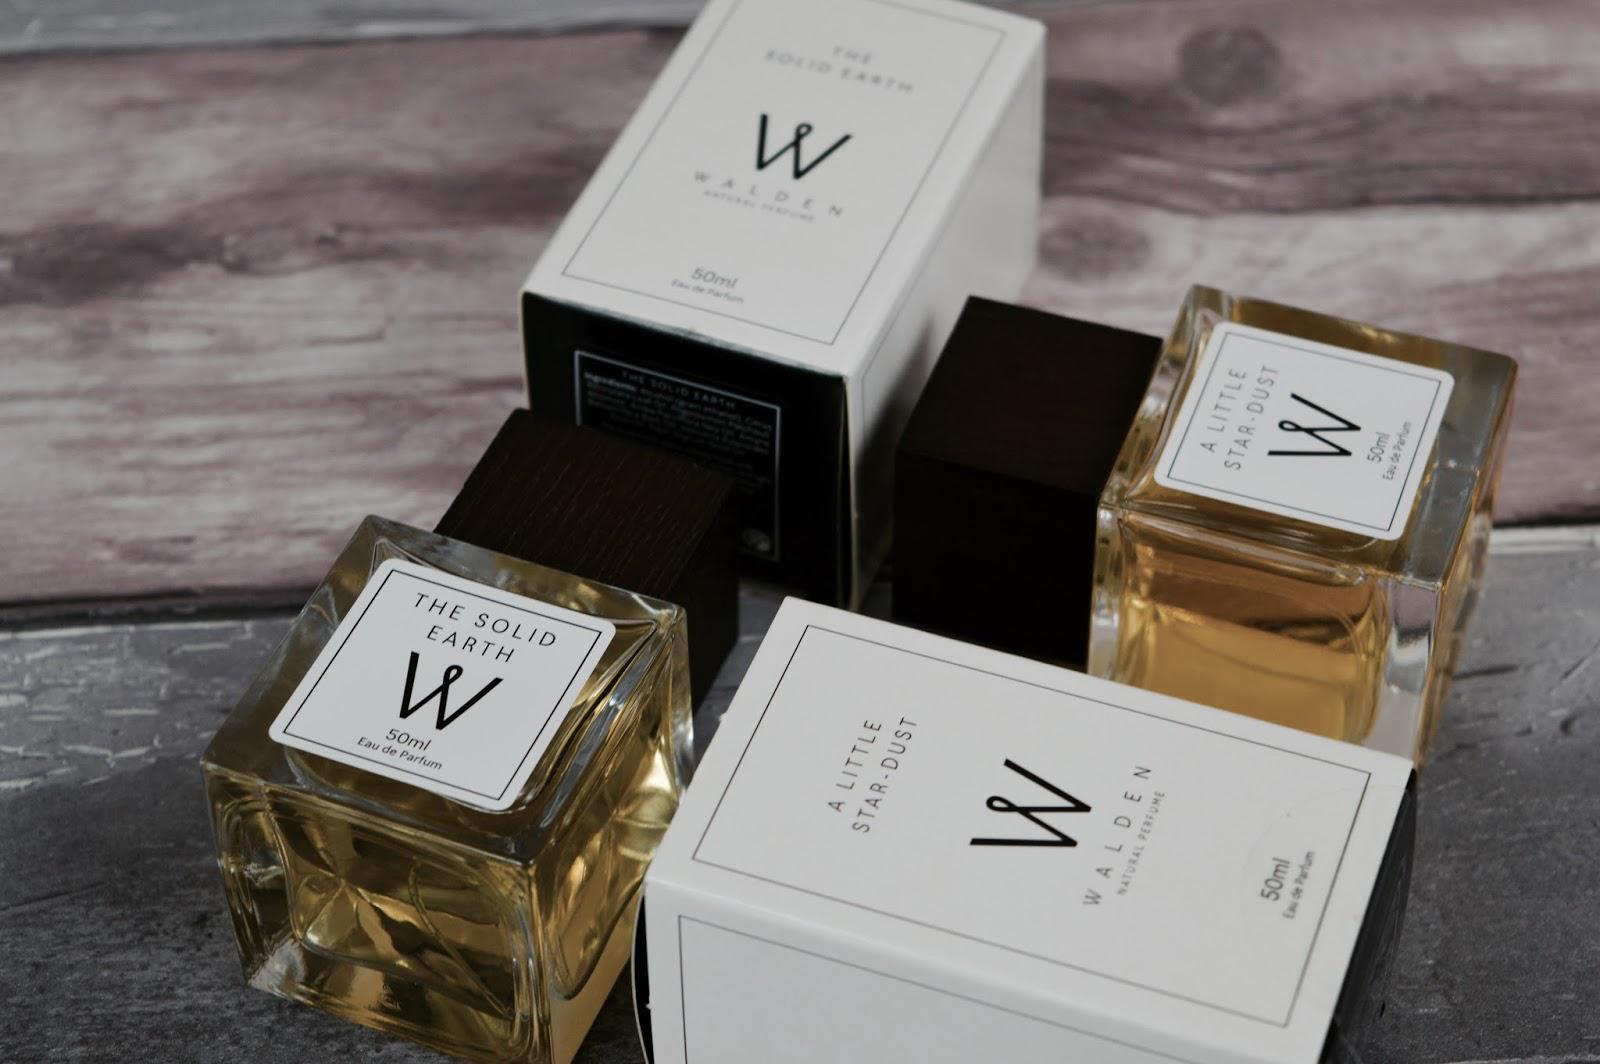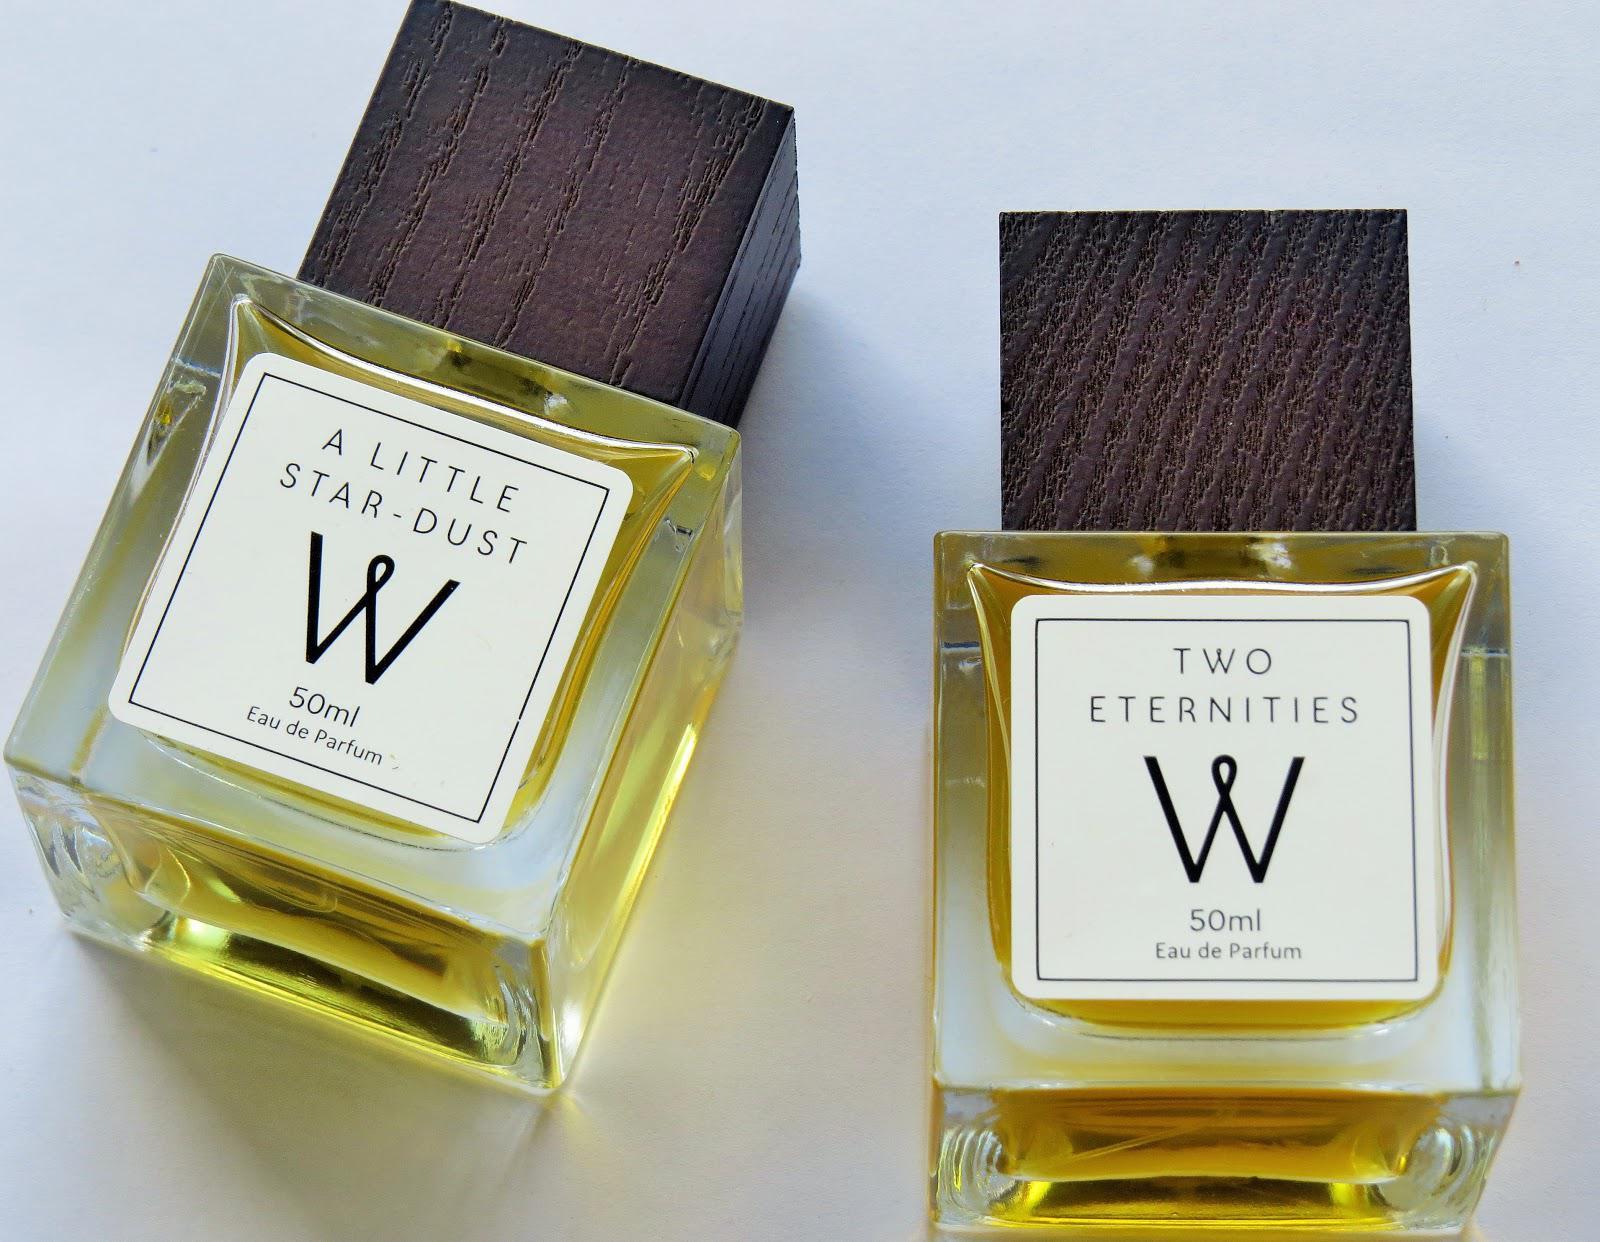The first image is the image on the left, the second image is the image on the right. Assess this claim about the two images: "Each image shows two cologne products, at least one of which is a bottle of yellowish liquid with a square lid.". Correct or not? Answer yes or no. Yes. The first image is the image on the left, the second image is the image on the right. For the images displayed, is the sentence "An image shows one square-bottled fragrance on the right side of its gold box, and not overlapping the box." factually correct? Answer yes or no. No. 